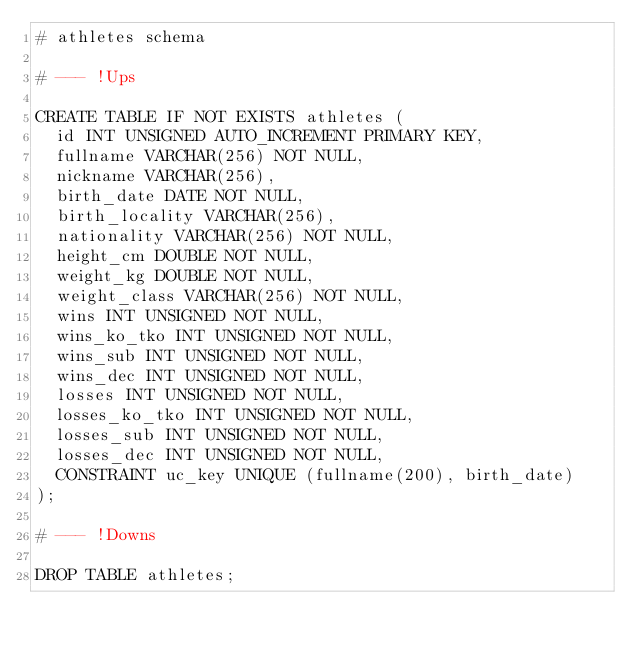Convert code to text. <code><loc_0><loc_0><loc_500><loc_500><_SQL_># athletes schema
 
# --- !Ups
 
CREATE TABLE IF NOT EXISTS athletes (
  id INT UNSIGNED AUTO_INCREMENT PRIMARY KEY,
  fullname VARCHAR(256) NOT NULL,
  nickname VARCHAR(256),
  birth_date DATE NOT NULL,
  birth_locality VARCHAR(256),
  nationality VARCHAR(256) NOT NULL,
  height_cm DOUBLE NOT NULL,
  weight_kg DOUBLE NOT NULL,
  weight_class VARCHAR(256) NOT NULL,
  wins INT UNSIGNED NOT NULL,
  wins_ko_tko INT UNSIGNED NOT NULL,
  wins_sub INT UNSIGNED NOT NULL,
  wins_dec INT UNSIGNED NOT NULL,
  losses INT UNSIGNED NOT NULL,
  losses_ko_tko INT UNSIGNED NOT NULL,
  losses_sub INT UNSIGNED NOT NULL,
  losses_dec INT UNSIGNED NOT NULL,
  CONSTRAINT uc_key UNIQUE (fullname(200), birth_date)
);
 
# --- !Downs
 
DROP TABLE athletes;
</code> 